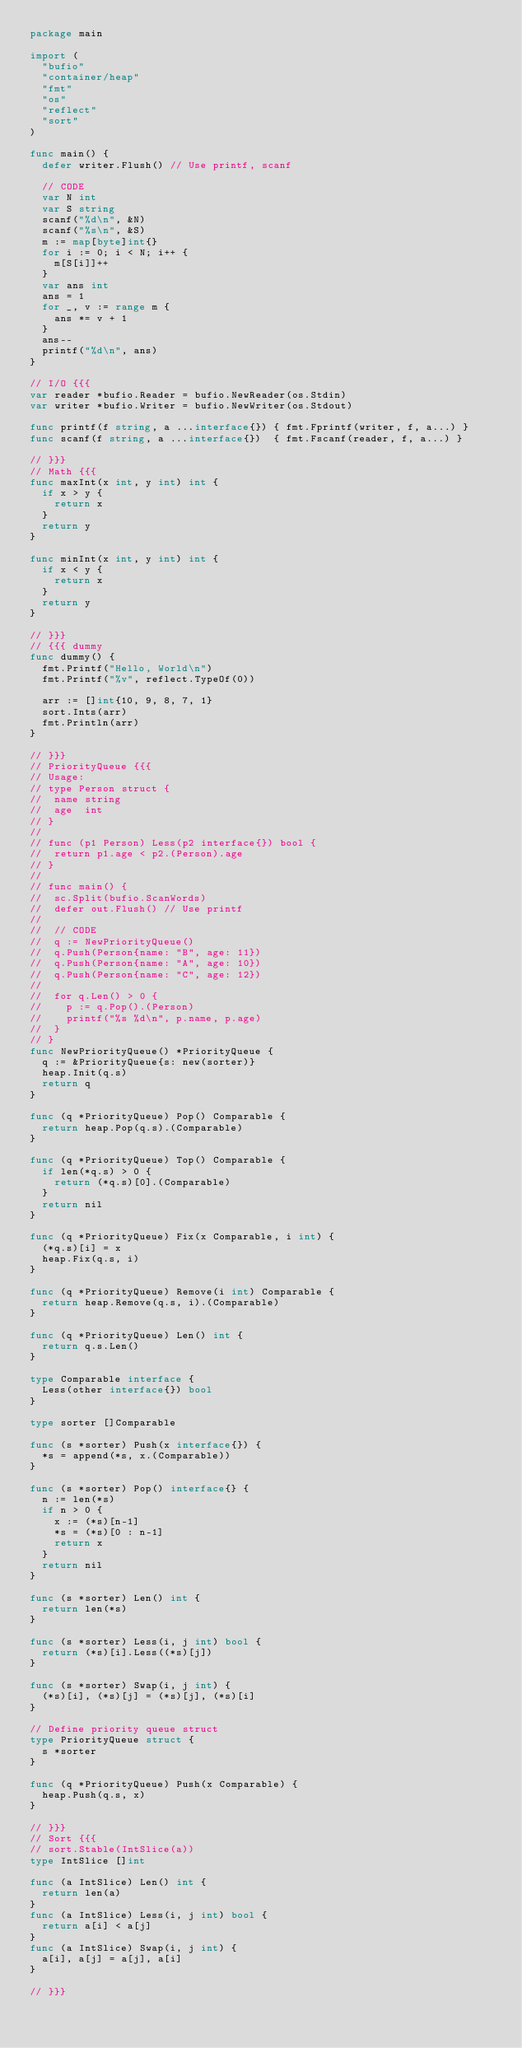<code> <loc_0><loc_0><loc_500><loc_500><_Go_>package main

import (
	"bufio"
	"container/heap"
	"fmt"
	"os"
	"reflect"
	"sort"
)

func main() {
	defer writer.Flush() // Use printf, scanf

	// CODE
	var N int
	var S string
	scanf("%d\n", &N)
	scanf("%s\n", &S)
	m := map[byte]int{}
	for i := 0; i < N; i++ {
		m[S[i]]++
	}
	var ans int
	ans = 1
	for _, v := range m {
		ans *= v + 1
	}
	ans--
	printf("%d\n", ans)
}

// I/O {{{
var reader *bufio.Reader = bufio.NewReader(os.Stdin)
var writer *bufio.Writer = bufio.NewWriter(os.Stdout)

func printf(f string, a ...interface{}) { fmt.Fprintf(writer, f, a...) }
func scanf(f string, a ...interface{})  { fmt.Fscanf(reader, f, a...) }

// }}}
// Math {{{
func maxInt(x int, y int) int {
	if x > y {
		return x
	}
	return y
}

func minInt(x int, y int) int {
	if x < y {
		return x
	}
	return y
}

// }}}
// {{{ dummy
func dummy() {
	fmt.Printf("Hello, World\n")
	fmt.Printf("%v", reflect.TypeOf(0))

	arr := []int{10, 9, 8, 7, 1}
	sort.Ints(arr)
	fmt.Println(arr)
}

// }}}
// PriorityQueue {{{
// Usage:
// type Person struct {
// 	name string
// 	age  int
// }
//
// func (p1 Person) Less(p2 interface{}) bool {
// 	return p1.age < p2.(Person).age
// }
//
// func main() {
// 	sc.Split(bufio.ScanWords)
// 	defer out.Flush() // Use printf
//
// 	// CODE
// 	q := NewPriorityQueue()
// 	q.Push(Person{name: "B", age: 11})
// 	q.Push(Person{name: "A", age: 10})
// 	q.Push(Person{name: "C", age: 12})
//
// 	for q.Len() > 0 {
// 		p := q.Pop().(Person)
// 		printf("%s %d\n", p.name, p.age)
// 	}
// }
func NewPriorityQueue() *PriorityQueue {
	q := &PriorityQueue{s: new(sorter)}
	heap.Init(q.s)
	return q
}

func (q *PriorityQueue) Pop() Comparable {
	return heap.Pop(q.s).(Comparable)
}

func (q *PriorityQueue) Top() Comparable {
	if len(*q.s) > 0 {
		return (*q.s)[0].(Comparable)
	}
	return nil
}

func (q *PriorityQueue) Fix(x Comparable, i int) {
	(*q.s)[i] = x
	heap.Fix(q.s, i)
}

func (q *PriorityQueue) Remove(i int) Comparable {
	return heap.Remove(q.s, i).(Comparable)
}

func (q *PriorityQueue) Len() int {
	return q.s.Len()
}

type Comparable interface {
	Less(other interface{}) bool
}

type sorter []Comparable

func (s *sorter) Push(x interface{}) {
	*s = append(*s, x.(Comparable))
}

func (s *sorter) Pop() interface{} {
	n := len(*s)
	if n > 0 {
		x := (*s)[n-1]
		*s = (*s)[0 : n-1]
		return x
	}
	return nil
}

func (s *sorter) Len() int {
	return len(*s)
}

func (s *sorter) Less(i, j int) bool {
	return (*s)[i].Less((*s)[j])
}

func (s *sorter) Swap(i, j int) {
	(*s)[i], (*s)[j] = (*s)[j], (*s)[i]
}

// Define priority queue struct
type PriorityQueue struct {
	s *sorter
}

func (q *PriorityQueue) Push(x Comparable) {
	heap.Push(q.s, x)
}

// }}}
// Sort {{{
// sort.Stable(IntSlice(a))
type IntSlice []int

func (a IntSlice) Len() int {
	return len(a)
}
func (a IntSlice) Less(i, j int) bool {
	return a[i] < a[j]
}
func (a IntSlice) Swap(i, j int) {
	a[i], a[j] = a[j], a[i]
}

// }}}
</code> 